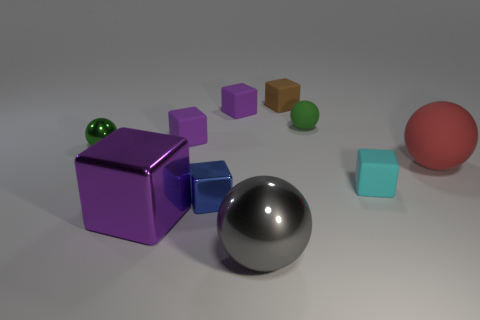There is a sphere that is right of the small green shiny ball and behind the large matte sphere; what material is it made of?
Your response must be concise. Rubber. What color is the large matte thing?
Your response must be concise. Red. Is there any other thing that is the same material as the tiny brown cube?
Your response must be concise. Yes. There is a brown thing on the left side of the small cyan rubber cube; what shape is it?
Provide a succinct answer. Cube. There is a small rubber cube that is in front of the big thing that is behind the tiny blue object; is there a shiny block behind it?
Provide a succinct answer. No. Is there any other thing that has the same shape as the red rubber object?
Your response must be concise. Yes. Is there a blue rubber thing?
Provide a short and direct response. No. Do the tiny green ball that is to the left of the gray metal sphere and the purple cube in front of the small metallic block have the same material?
Provide a short and direct response. Yes. There is a metal ball behind the rubber block in front of the metallic object that is behind the small cyan thing; what is its size?
Provide a succinct answer. Small. How many large purple things are the same material as the cyan cube?
Your answer should be compact. 0. 